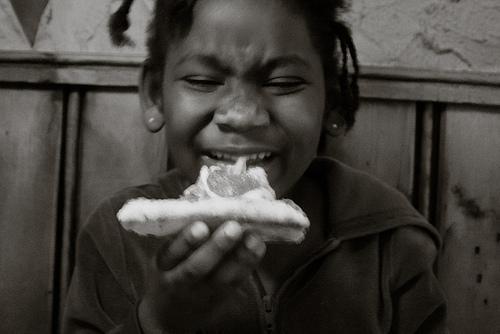How many girls are there?
Give a very brief answer. 1. How many people are in the picture?
Give a very brief answer. 1. How many slices of pizza are in the picture?
Give a very brief answer. 1. 